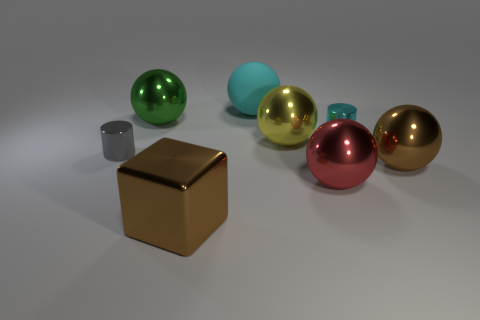Subtract 1 balls. How many balls are left? 4 Subtract all yellow spheres. How many spheres are left? 4 Subtract all yellow balls. How many balls are left? 4 Subtract all purple spheres. Subtract all gray cylinders. How many spheres are left? 5 Add 1 green metal balls. How many objects exist? 9 Subtract all cylinders. How many objects are left? 6 Add 3 metallic balls. How many metallic balls exist? 7 Subtract 0 green cubes. How many objects are left? 8 Subtract all big blue metal things. Subtract all tiny gray metallic cylinders. How many objects are left? 7 Add 5 big matte balls. How many big matte balls are left? 6 